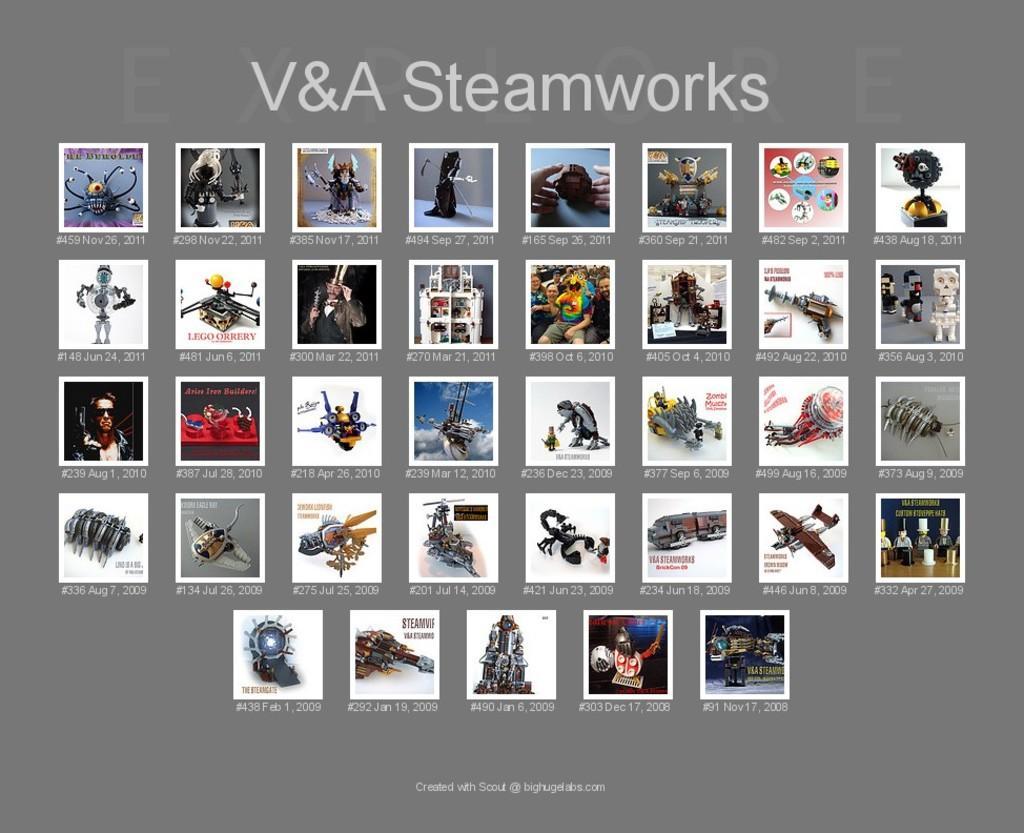Can you describe this image briefly? In this image we can see there is an object which looks like a screen. And there are different types of images on the screen and there is a text on it. 